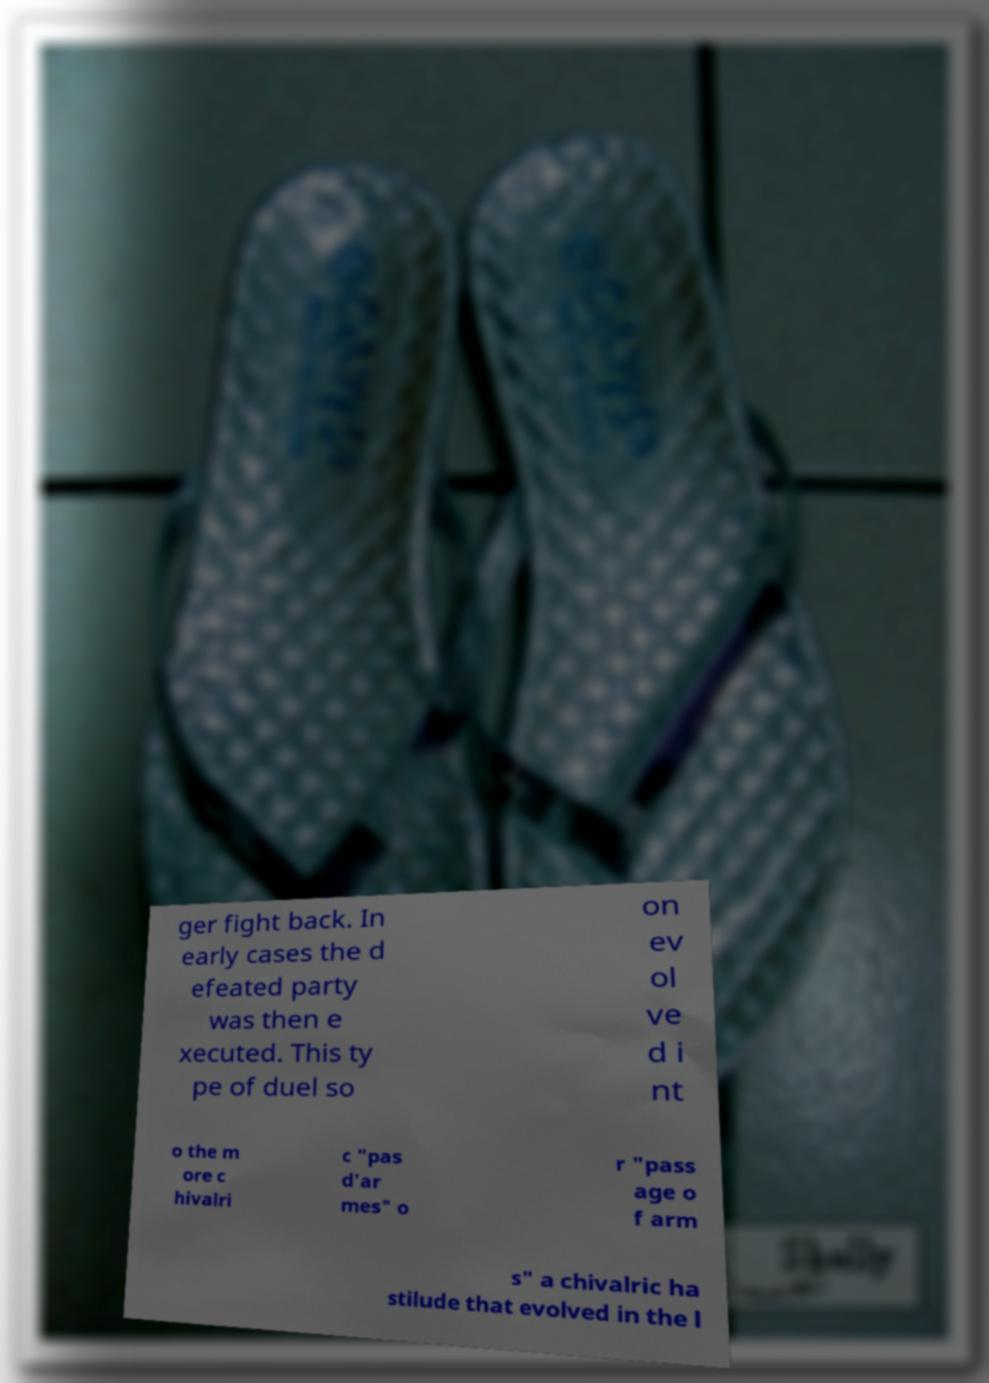Could you assist in decoding the text presented in this image and type it out clearly? ger fight back. In early cases the d efeated party was then e xecuted. This ty pe of duel so on ev ol ve d i nt o the m ore c hivalri c "pas d'ar mes" o r "pass age o f arm s" a chivalric ha stilude that evolved in the l 